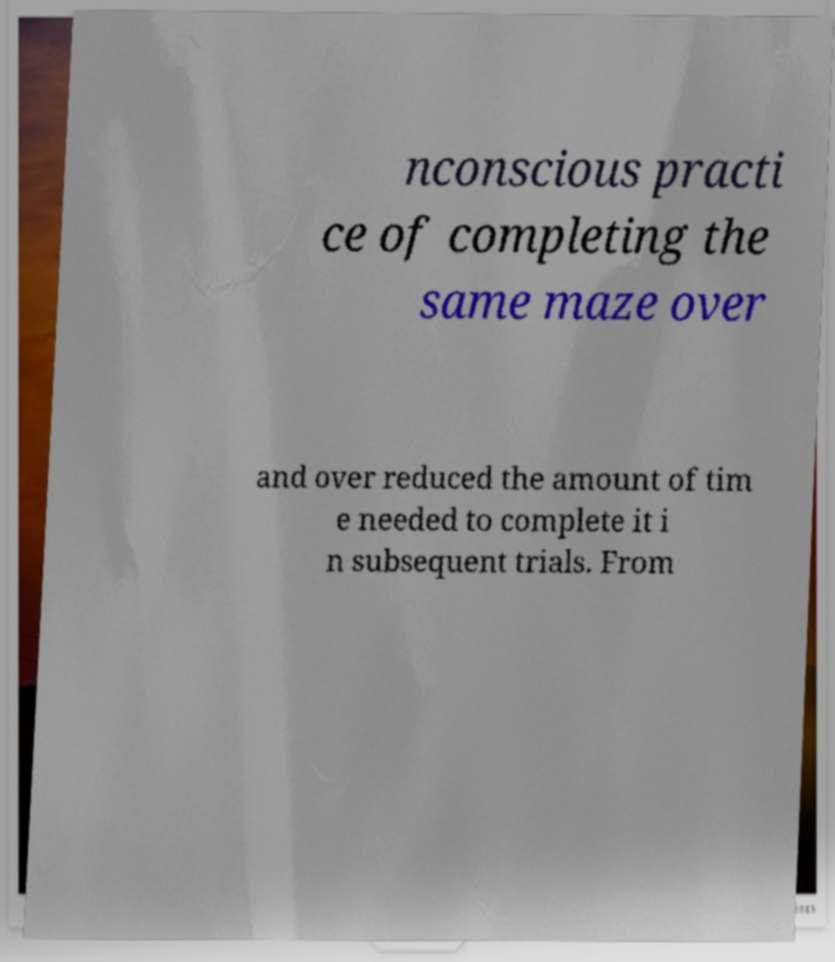Can you accurately transcribe the text from the provided image for me? nconscious practi ce of completing the same maze over and over reduced the amount of tim e needed to complete it i n subsequent trials. From 